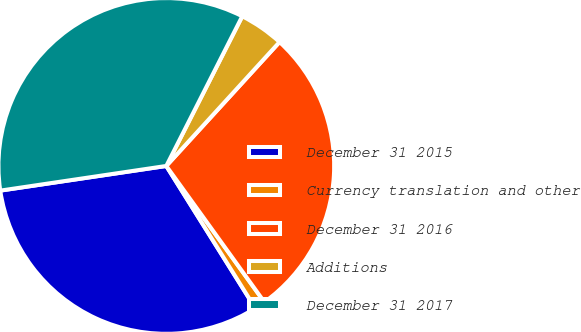<chart> <loc_0><loc_0><loc_500><loc_500><pie_chart><fcel>December 31 2015<fcel>Currency translation and other<fcel>December 31 2016<fcel>Additions<fcel>December 31 2017<nl><fcel>31.55%<fcel>1.04%<fcel>28.28%<fcel>4.31%<fcel>34.82%<nl></chart> 